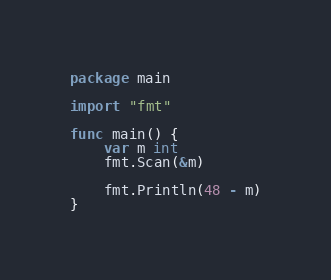<code> <loc_0><loc_0><loc_500><loc_500><_Go_>package main

import "fmt"

func main() {
	var m int
	fmt.Scan(&m)

	fmt.Println(48 - m)
}
</code> 